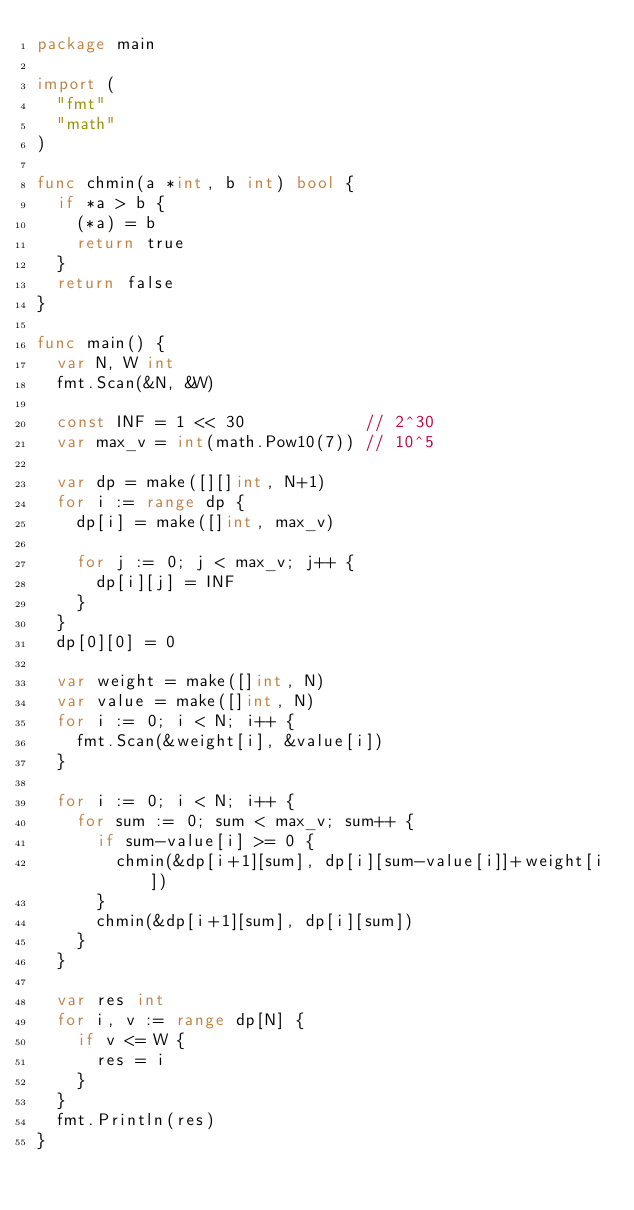<code> <loc_0><loc_0><loc_500><loc_500><_Go_>package main

import (
	"fmt"
	"math"
)

func chmin(a *int, b int) bool {
	if *a > b {
		(*a) = b
		return true
	}
	return false
}

func main() {
	var N, W int
	fmt.Scan(&N, &W)

	const INF = 1 << 30            // 2^30
	var max_v = int(math.Pow10(7)) // 10^5

	var dp = make([][]int, N+1)
	for i := range dp {
		dp[i] = make([]int, max_v)

		for j := 0; j < max_v; j++ {
			dp[i][j] = INF
		}
	}
	dp[0][0] = 0

	var weight = make([]int, N)
	var value = make([]int, N)
	for i := 0; i < N; i++ {
		fmt.Scan(&weight[i], &value[i])
	}

	for i := 0; i < N; i++ {
		for sum := 0; sum < max_v; sum++ {
			if sum-value[i] >= 0 {
				chmin(&dp[i+1][sum], dp[i][sum-value[i]]+weight[i])
			}
			chmin(&dp[i+1][sum], dp[i][sum])
		}
	}

	var res int
	for i, v := range dp[N] {
		if v <= W {
			res = i
		}
	}
	fmt.Println(res)
}</code> 